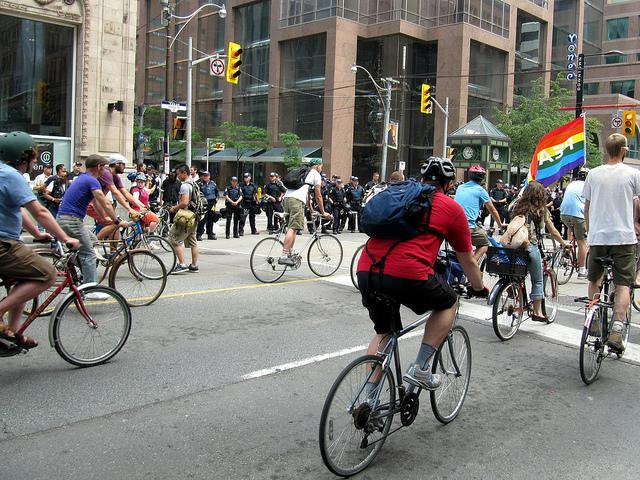Why are the men in uniforms standing by the road? Please explain your reasoning. security. The police officers are there for safety 